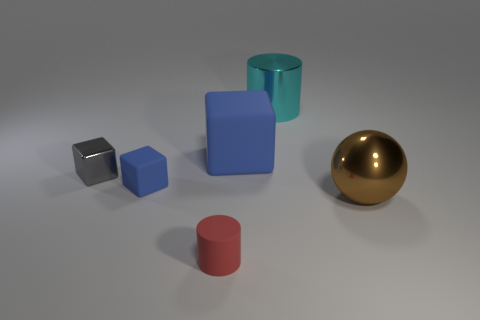Subtract all large rubber blocks. How many blocks are left? 2 Subtract all balls. How many objects are left? 5 Add 4 tiny cylinders. How many objects exist? 10 Subtract 2 cylinders. How many cylinders are left? 0 Subtract all blue cubes. How many cubes are left? 1 Subtract 0 green cubes. How many objects are left? 6 Subtract all yellow cylinders. Subtract all brown spheres. How many cylinders are left? 2 Subtract all gray cubes. How many green cylinders are left? 0 Subtract all big metallic objects. Subtract all large rubber objects. How many objects are left? 3 Add 6 cyan metallic things. How many cyan metallic things are left? 7 